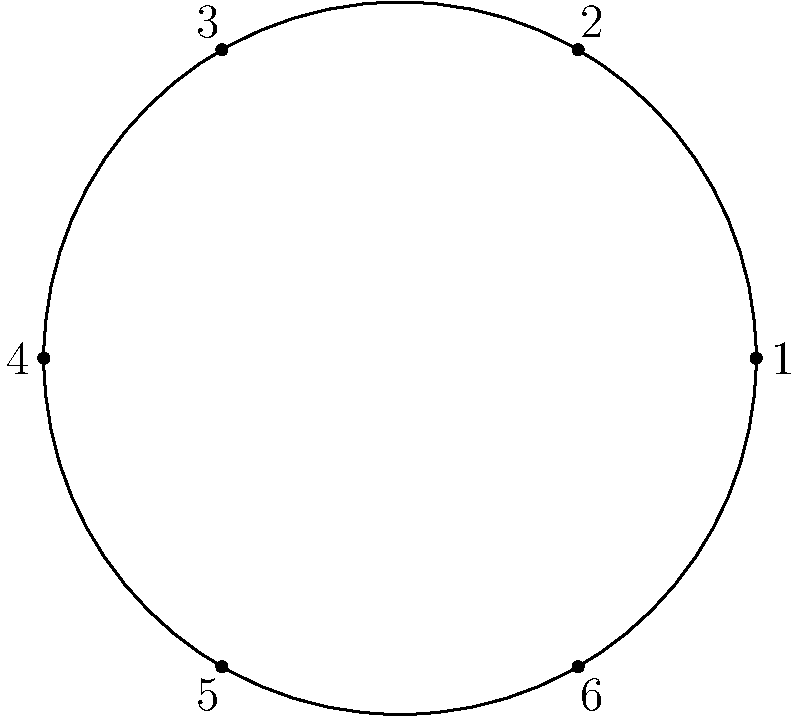Consider a cyclic group of order 6 represented by the circular diagram above. If the generator of this group is element 1, what is the order of element 4? To find the order of element 4 in this cyclic group, we can follow these steps:

1) In a cyclic group of order 6, the elements are powers of the generator. If 1 is the generator, then:
   $1 = 1^1$, $2 = 1^2$, $3 = 1^3$, $4 = 1^4$, $5 = 1^5$, $6 = 1^6 = 1^0$

2) The order of an element is the smallest positive integer $k$ such that $a^k = e$ (the identity element).

3) For element 4:
   $4^1 = 1^4$
   $4^2 = (1^4)^2 = 1^8 = 1^2 = 2$
   $4^3 = (1^4)^3 = 1^{12} = 1^0 = 6$ (the identity element)

4) We see that $4^3 = 6$, which is the identity element in this group.

5) Therefore, the smallest positive integer $k$ such that $4^k = e$ is 3.
Answer: 3 